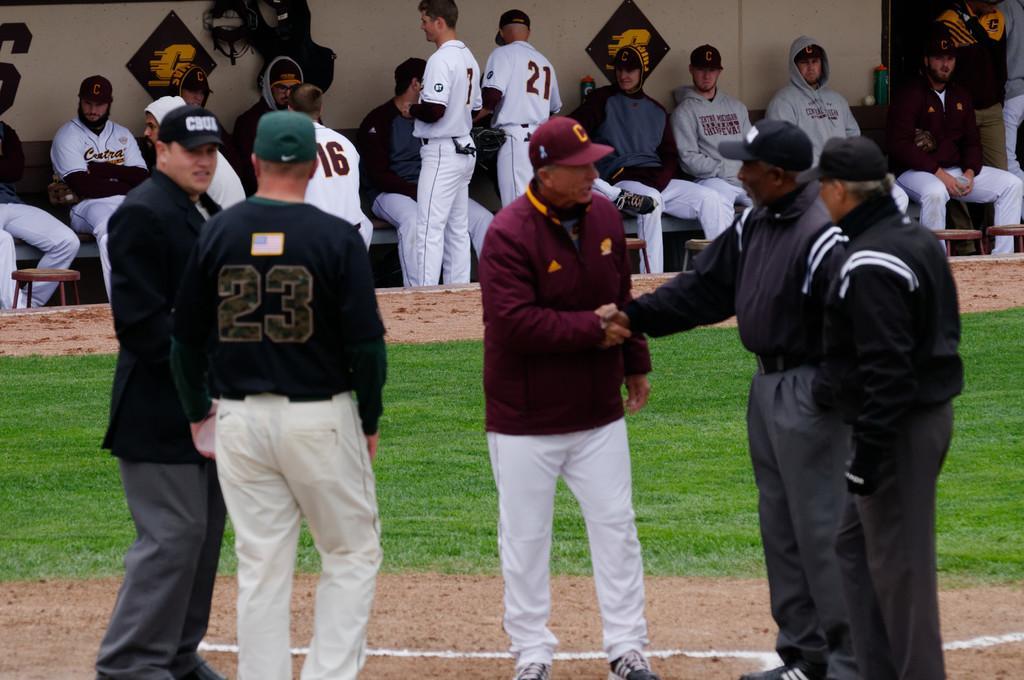How would you summarize this image in a sentence or two? This picture might be taken inside a playground. In this image, we can see a group of people are standing on the grass. In the background, we can see a group of people is sitting on the chair and a wall, for photo frames are attached to that wall. At the bottom, we can see a grass and a land with some stones. 